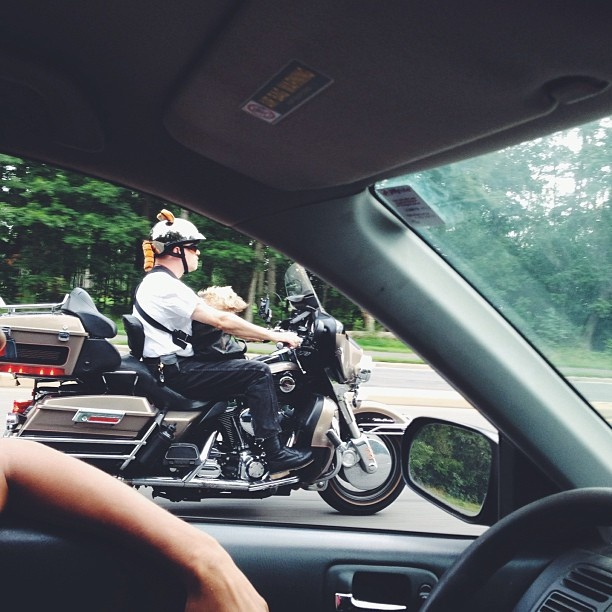Describe the objects in this image and their specific colors. I can see motorcycle in black, darkgray, gray, and lightgray tones, people in black, lightgray, tan, and maroon tones, people in black, white, and gray tones, dog in black, white, darkgray, and gray tones, and dog in black, ivory, tan, and darkgray tones in this image. 